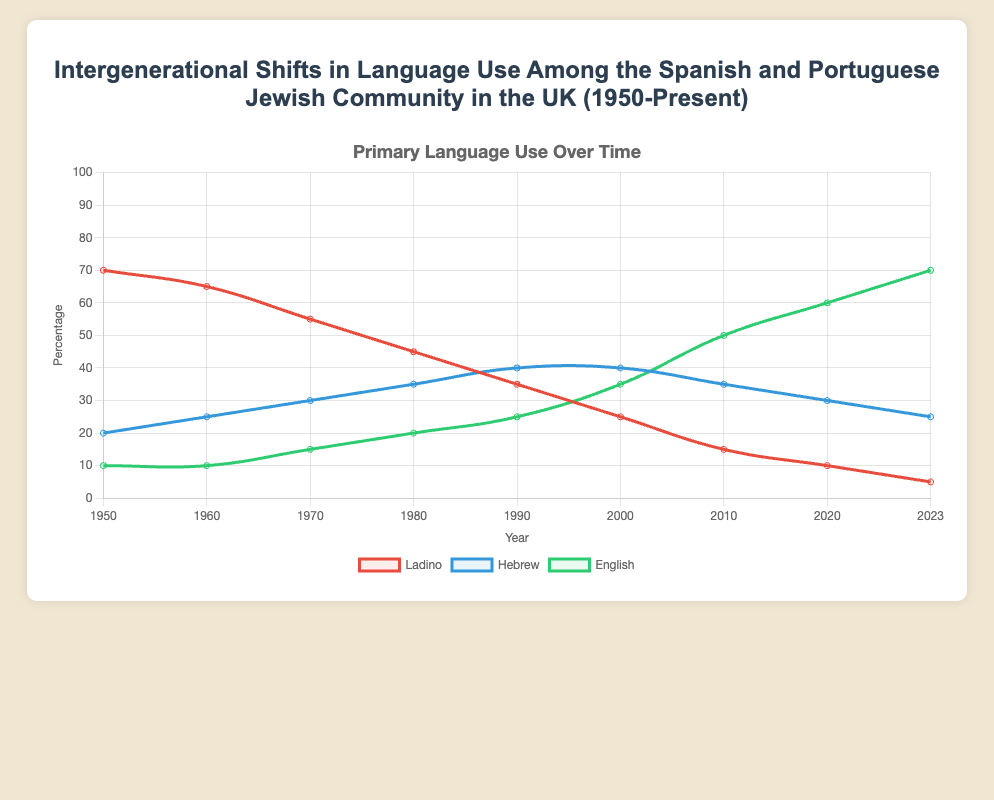What primary language showed the most consistent increase in usage over time? By observing the plot, you can see the trend lines. Ladino decreases consistently, Hebrew slightly fluctuates but generally increases and then stabilizes, whereas English shows a consistent increase from 1950 to 2023.
Answer: English What was the percentage of the population that spoke Ladino and Hebrew combined in 1990? To find this, add the percentages of people who spoke Ladino and Hebrew in 1990. From the data, Ladino was 35% and Hebrew was 40%, so 35 + 40 = 75%.
Answer: 75% Which year shows the closest percentage use between Hebrew and English? Compare the differences between Hebrew and English across the years visually. In 2000, the percentage for Hebrew is 40% and English is 35%, minimal difference of 5%.
Answer: 2000 Compare the changes in primary language usage of Ladino and English from 1950 to 2023. Which one had the greater change? Calculate the difference in percentage for both languages between the years 1950 and 2023. Ladino: 70% (1950) - 5% (2023) = 65%, English: 70% (2023) - 10% (1950) = 60%. Ladino shows a greater change.
Answer: Ladino In what year does the usage of English surpass Hebrew as the primary language? By looking at the plot, identify the first year where the English percentage line is above the Hebrew line. This occurs in the year 2000.
Answer: 2000 What's the median percentage for Ladino usage over the years provided? To find the median, list out the percentages of Ladino from all the years and find the middle value. The values are (70, 65, 55, 45, 35, 25, 15, 10, 5). The middle value when listed in order is 35%, which is median in this data set.
Answer: 35% How many years did the Hebrew percentage remain the same, starting from the data set? By reviewing the Hebrew trend on the plot, we notice that from 2000 to 2010, and then from 2010 to 2020, the percentage remains 40% and 35% respectively. So, it remained the same for about 10 years in two periods cumulatively.
Answer: 10 years During which decade did the primary language Ladino experience the steepest decline? From 1950 to 2023, the steepest decline can be visualized by looking at the slope of the Ladino line. The steepest decline visually occurs between 1970 and 1980, from 55% to 45%, a 10% drop.
Answer: 1970-1980 What is the percentage difference between the highest and lowest values for Hebrew across the years? To find this, identify the highest and lowest Hebrew percentages from the data. Highest is 40% (1990, 2000), lowest is 20% (1950). So, 40% - 20% = 20%.
Answer: 20% Which language had less than 50% usage throughout the time period? Reviewing the plot, Ladino always stays below 50% from 1950 to 2023. Neither Hebrew nor English fits this pattern.
Answer: Ladino 